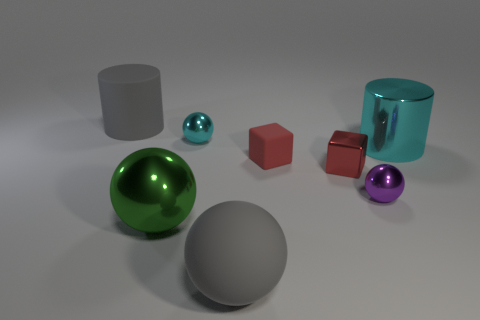How many things are either tiny red metal cylinders or big green things?
Your answer should be very brief. 1. How many things are either large metallic objects or balls that are behind the red metallic block?
Ensure brevity in your answer.  3. Is the green thing made of the same material as the small purple thing?
Your answer should be very brief. Yes. How many other things are there of the same material as the cyan ball?
Your response must be concise. 4. Are there more big green matte blocks than matte cylinders?
Give a very brief answer. No. There is a tiny object that is left of the red rubber thing; does it have the same shape as the big green metal object?
Make the answer very short. Yes. Are there fewer big cyan cylinders than blue objects?
Offer a very short reply. No. What is the material of the cyan object that is the same size as the purple metallic object?
Make the answer very short. Metal. There is a big rubber cylinder; is its color the same as the sphere to the right of the large gray rubber sphere?
Give a very brief answer. No. Are there fewer purple objects on the right side of the small red rubber object than tiny cyan matte balls?
Your answer should be compact. No. 